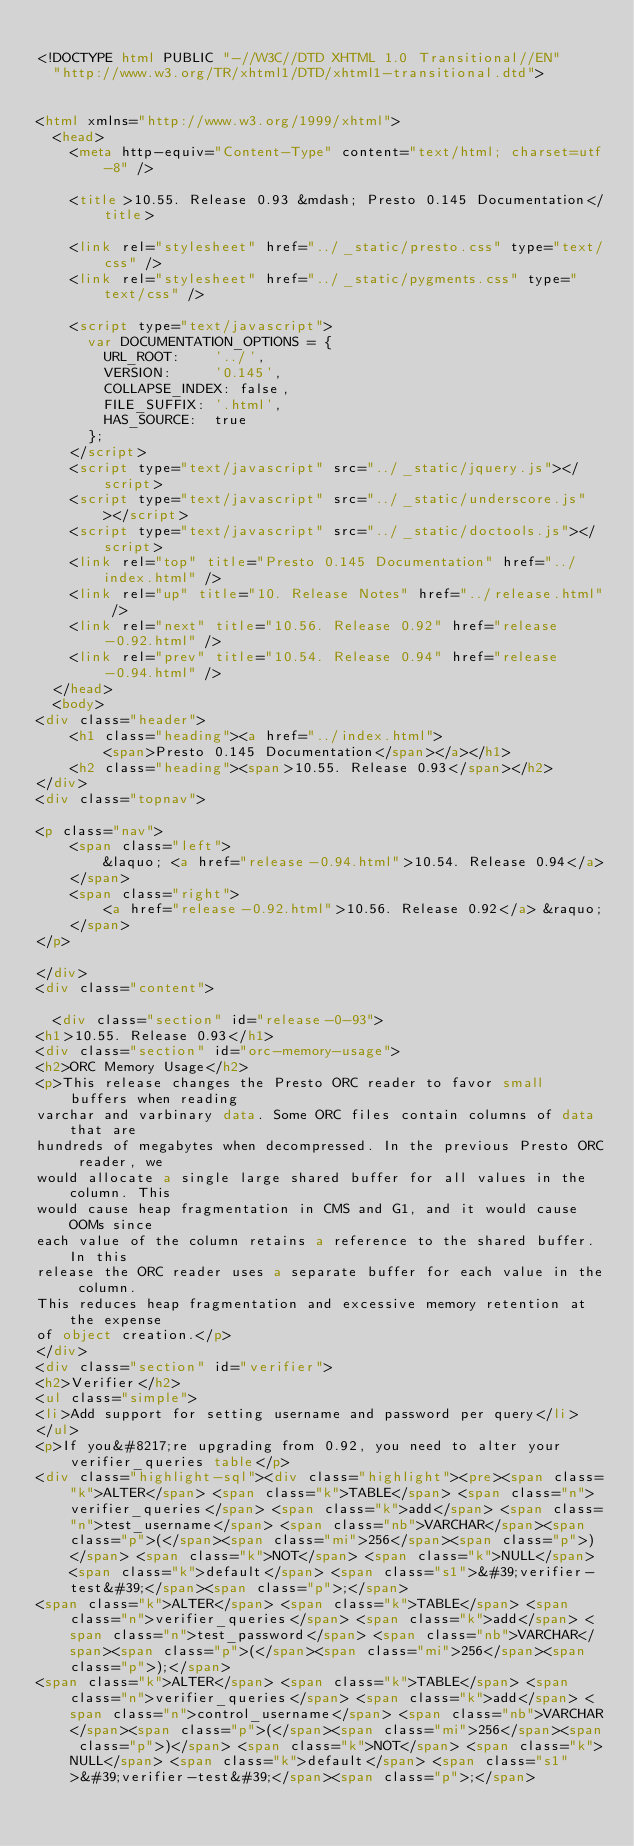Convert code to text. <code><loc_0><loc_0><loc_500><loc_500><_HTML_>
<!DOCTYPE html PUBLIC "-//W3C//DTD XHTML 1.0 Transitional//EN"
  "http://www.w3.org/TR/xhtml1/DTD/xhtml1-transitional.dtd">


<html xmlns="http://www.w3.org/1999/xhtml">
  <head>
    <meta http-equiv="Content-Type" content="text/html; charset=utf-8" />
    
    <title>10.55. Release 0.93 &mdash; Presto 0.145 Documentation</title>
    
    <link rel="stylesheet" href="../_static/presto.css" type="text/css" />
    <link rel="stylesheet" href="../_static/pygments.css" type="text/css" />
    
    <script type="text/javascript">
      var DOCUMENTATION_OPTIONS = {
        URL_ROOT:    '../',
        VERSION:     '0.145',
        COLLAPSE_INDEX: false,
        FILE_SUFFIX: '.html',
        HAS_SOURCE:  true
      };
    </script>
    <script type="text/javascript" src="../_static/jquery.js"></script>
    <script type="text/javascript" src="../_static/underscore.js"></script>
    <script type="text/javascript" src="../_static/doctools.js"></script>
    <link rel="top" title="Presto 0.145 Documentation" href="../index.html" />
    <link rel="up" title="10. Release Notes" href="../release.html" />
    <link rel="next" title="10.56. Release 0.92" href="release-0.92.html" />
    <link rel="prev" title="10.54. Release 0.94" href="release-0.94.html" /> 
  </head>
  <body>
<div class="header">
    <h1 class="heading"><a href="../index.html">
        <span>Presto 0.145 Documentation</span></a></h1>
    <h2 class="heading"><span>10.55. Release 0.93</span></h2>
</div>
<div class="topnav">
    
<p class="nav">
    <span class="left">
        &laquo; <a href="release-0.94.html">10.54. Release 0.94</a>
    </span>
    <span class="right">
        <a href="release-0.92.html">10.56. Release 0.92</a> &raquo;
    </span>
</p>

</div>
<div class="content">
    
  <div class="section" id="release-0-93">
<h1>10.55. Release 0.93</h1>
<div class="section" id="orc-memory-usage">
<h2>ORC Memory Usage</h2>
<p>This release changes the Presto ORC reader to favor small buffers when reading
varchar and varbinary data. Some ORC files contain columns of data that are
hundreds of megabytes when decompressed. In the previous Presto ORC reader, we
would allocate a single large shared buffer for all values in the column. This
would cause heap fragmentation in CMS and G1, and it would cause OOMs since
each value of the column retains a reference to the shared buffer. In this
release the ORC reader uses a separate buffer for each value in the column.
This reduces heap fragmentation and excessive memory retention at the expense
of object creation.</p>
</div>
<div class="section" id="verifier">
<h2>Verifier</h2>
<ul class="simple">
<li>Add support for setting username and password per query</li>
</ul>
<p>If you&#8217;re upgrading from 0.92, you need to alter your verifier_queries table</p>
<div class="highlight-sql"><div class="highlight"><pre><span class="k">ALTER</span> <span class="k">TABLE</span> <span class="n">verifier_queries</span> <span class="k">add</span> <span class="n">test_username</span> <span class="nb">VARCHAR</span><span class="p">(</span><span class="mi">256</span><span class="p">)</span> <span class="k">NOT</span> <span class="k">NULL</span> <span class="k">default</span> <span class="s1">&#39;verifier-test&#39;</span><span class="p">;</span>
<span class="k">ALTER</span> <span class="k">TABLE</span> <span class="n">verifier_queries</span> <span class="k">add</span> <span class="n">test_password</span> <span class="nb">VARCHAR</span><span class="p">(</span><span class="mi">256</span><span class="p">);</span>
<span class="k">ALTER</span> <span class="k">TABLE</span> <span class="n">verifier_queries</span> <span class="k">add</span> <span class="n">control_username</span> <span class="nb">VARCHAR</span><span class="p">(</span><span class="mi">256</span><span class="p">)</span> <span class="k">NOT</span> <span class="k">NULL</span> <span class="k">default</span> <span class="s1">&#39;verifier-test&#39;</span><span class="p">;</span></code> 